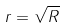<formula> <loc_0><loc_0><loc_500><loc_500>r = { \sqrt { R } }</formula> 